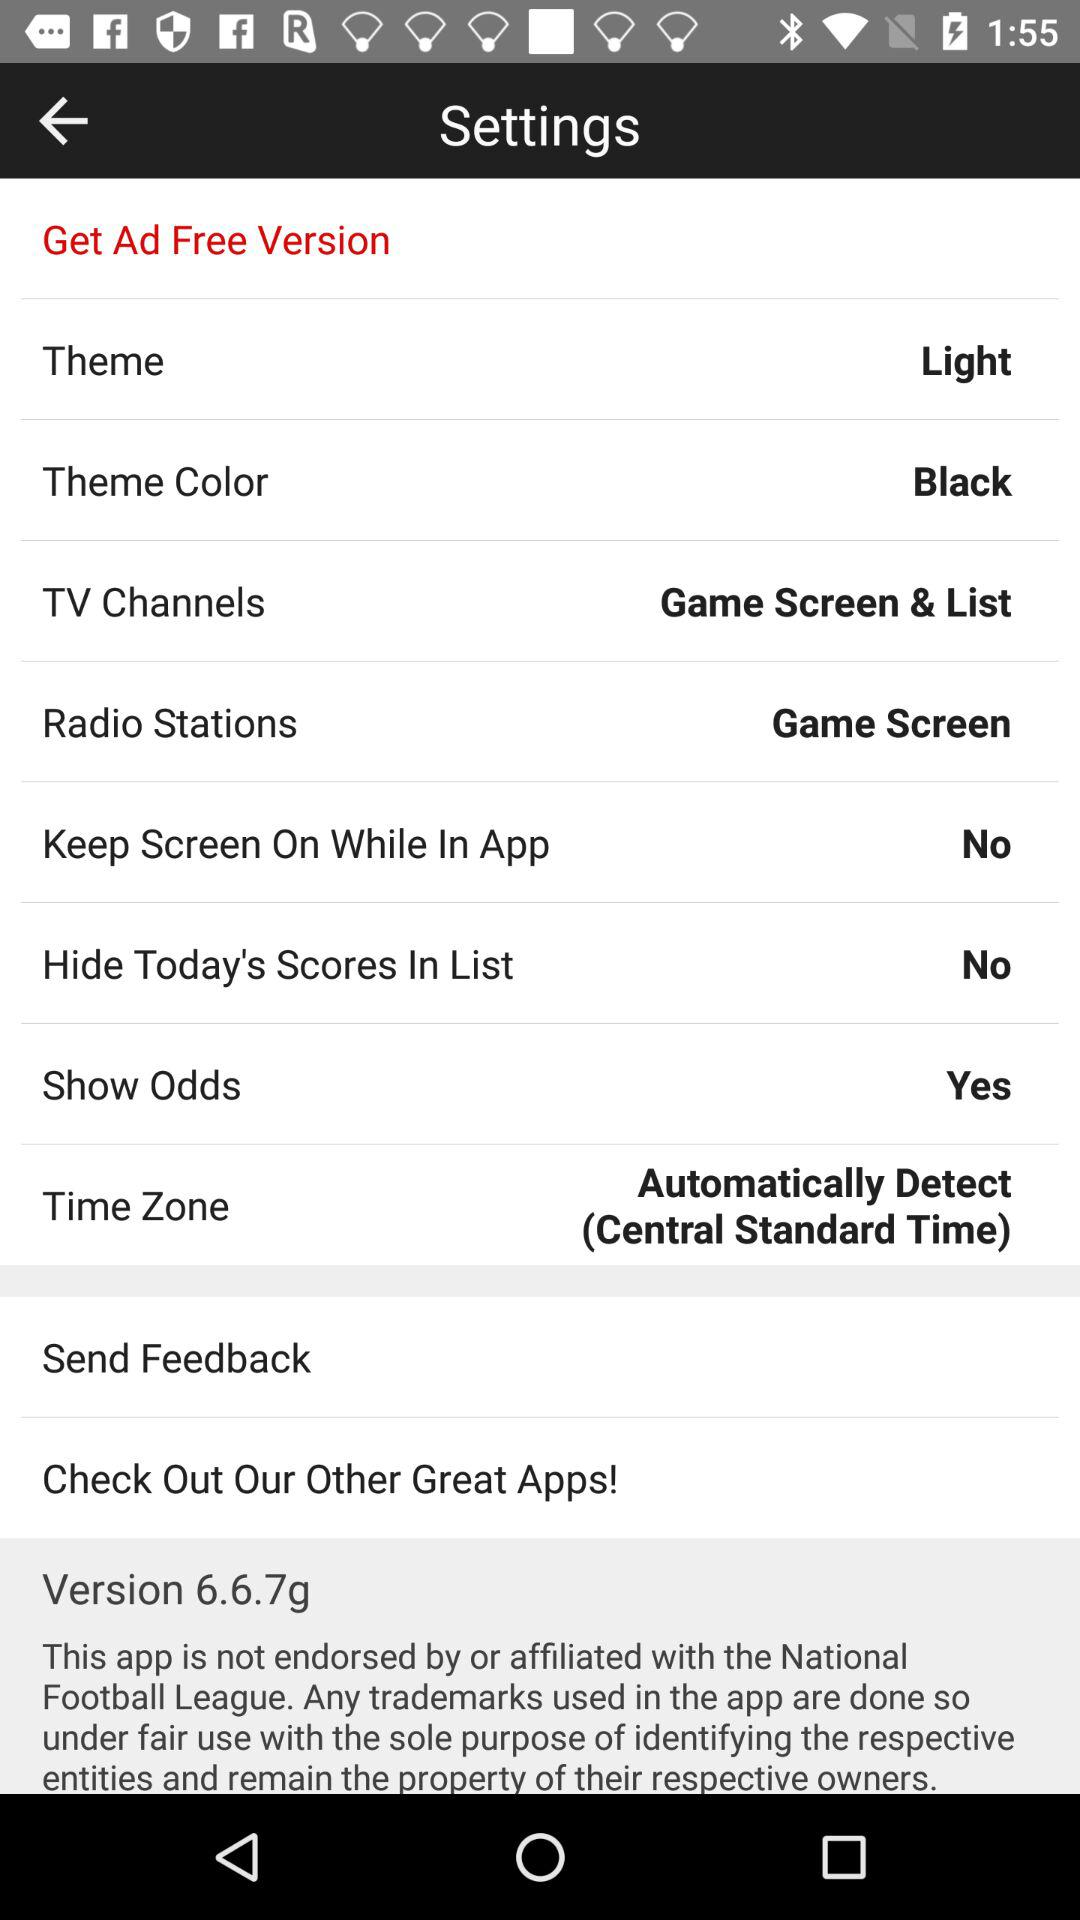What are the selected TV channels? The selected TV channels are "Game Screen" and "List". 